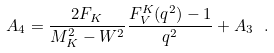Convert formula to latex. <formula><loc_0><loc_0><loc_500><loc_500>A _ { 4 } = \frac { 2 F _ { K } } { M _ { K } ^ { 2 } - W ^ { 2 } } \frac { F _ { V } ^ { K } ( q ^ { 2 } ) - 1 } { q ^ { 2 } } + A _ { 3 } \ .</formula> 